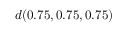Convert formula to latex. <formula><loc_0><loc_0><loc_500><loc_500>d ( 0 . 7 5 , 0 . 7 5 , 0 . 7 5 )</formula> 